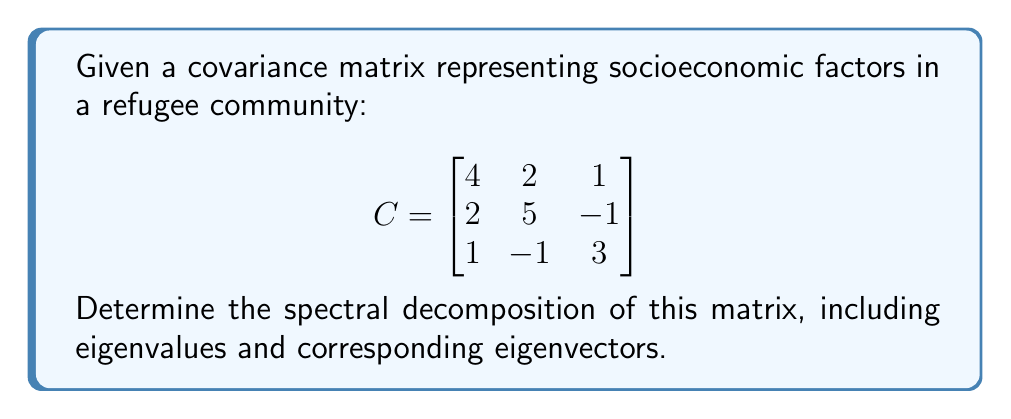Provide a solution to this math problem. To find the spectral decomposition of the covariance matrix $C$, we need to follow these steps:

1. Find the eigenvalues of $C$:
   Solve the characteristic equation $\det(C - \lambda I) = 0$
   
   $$\det\begin{pmatrix}
   4-\lambda & 2 & 1 \\
   2 & 5-\lambda & -1 \\
   1 & -1 & 3-\lambda
   \end{pmatrix} = 0$$
   
   Expanding this determinant gives:
   $(\lambda-1)(\lambda-3)(\lambda-8) = 0$
   
   So, the eigenvalues are $\lambda_1 = 1$, $\lambda_2 = 3$, and $\lambda_3 = 8$.

2. Find the eigenvectors for each eigenvalue:

   For $\lambda_1 = 1$:
   Solve $(C - I)v = 0$
   $$\begin{pmatrix}
   3 & 2 & 1 \\
   2 & 4 & -1 \\
   1 & -1 & 2
   \end{pmatrix}\begin{pmatrix}
   v_1 \\ v_2 \\ v_3
   \end{pmatrix} = \begin{pmatrix}
   0 \\ 0 \\ 0
   \end{pmatrix}$$
   
   Solving this system gives $v_1 = \begin{pmatrix} 1 \\ -1 \\ 1 \end{pmatrix}$

   Similarly, for $\lambda_2 = 3$ and $\lambda_3 = 8$, we get:
   $v_2 = \begin{pmatrix} -1 \\ 0 \\ 1 \end{pmatrix}$ and 
   $v_3 = \begin{pmatrix} 1 \\ 2 \\ 1 \end{pmatrix}$

3. Normalize the eigenvectors:
   $u_1 = \frac{1}{\sqrt{3}}\begin{pmatrix} 1 \\ -1 \\ 1 \end{pmatrix}$
   $u_2 = \frac{1}{\sqrt{2}}\begin{pmatrix} -1 \\ 0 \\ 1 \end{pmatrix}$
   $u_3 = \frac{1}{\sqrt{6}}\begin{pmatrix} 1 \\ 2 \\ 1 \end{pmatrix}$

4. Form the spectral decomposition:
   $C = U\Lambda U^T$
   
   Where $U = [u_1 \; u_2 \; u_3]$ and $\Lambda = \text{diag}(\lambda_1, \lambda_2, \lambda_3)$
Answer: $C = U\Lambda U^T$, where $U = [\frac{1}{\sqrt{3}}\begin{pmatrix} 1 \\ -1 \\ 1 \end{pmatrix} \; \frac{1}{\sqrt{2}}\begin{pmatrix} -1 \\ 0 \\ 1 \end{pmatrix} \; \frac{1}{\sqrt{6}}\begin{pmatrix} 1 \\ 2 \\ 1 \end{pmatrix}]$ and $\Lambda = \text{diag}(1, 3, 8)$ 